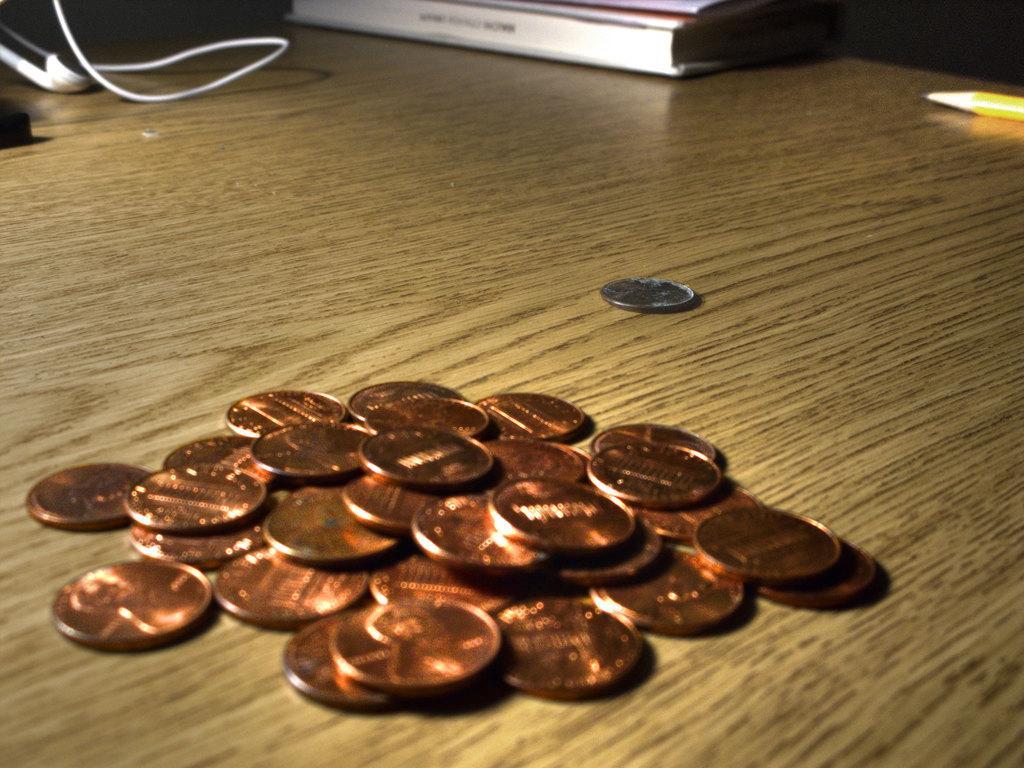In one or two sentences, can you explain what this image depicts? In the picture we can see a wooden table with a group of copper coins on it and some far away we can see a silver coin and behind it, we can see books, pencil and wire which is white in color. 